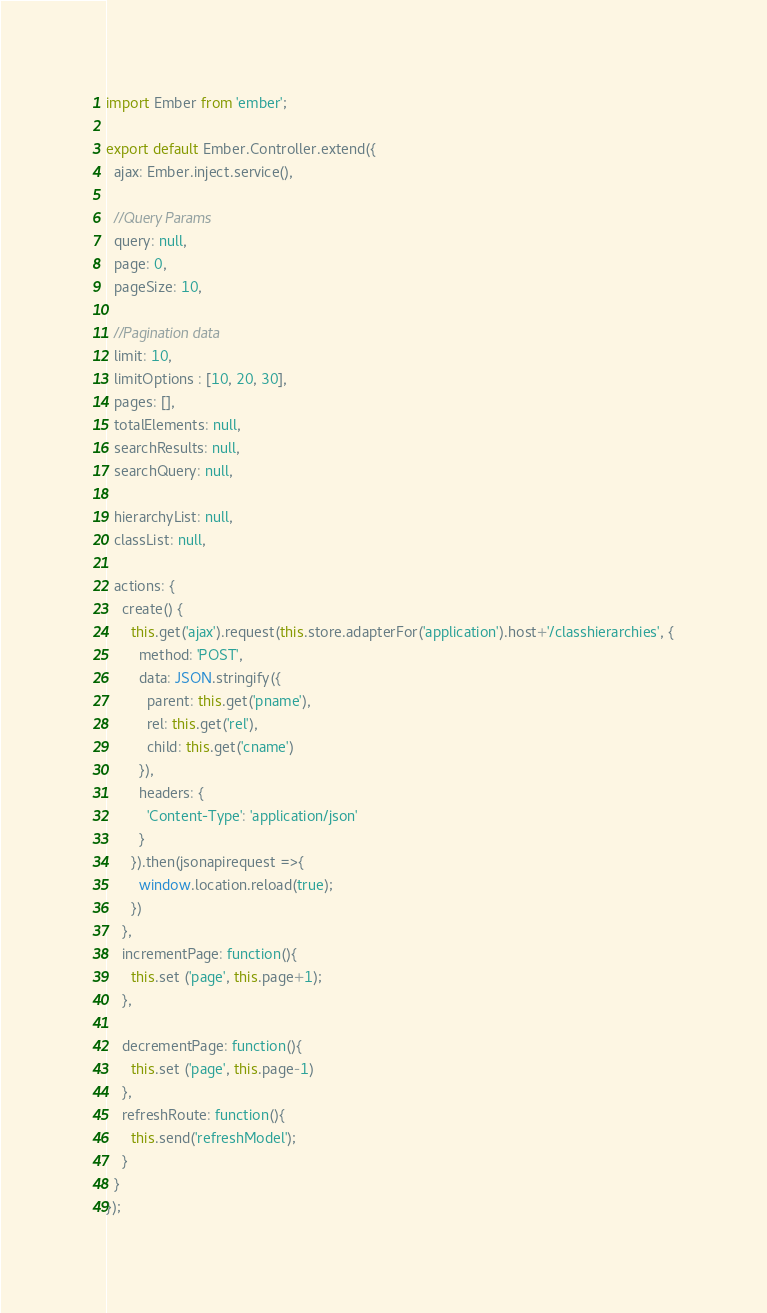<code> <loc_0><loc_0><loc_500><loc_500><_JavaScript_>import Ember from 'ember';

export default Ember.Controller.extend({
  ajax: Ember.inject.service(),

  //Query Params
  query: null,
  page: 0,
  pageSize: 10,

  //Pagination data
  limit: 10,
  limitOptions : [10, 20, 30],
  pages: [],
  totalElements: null,
  searchResults: null,
  searchQuery: null,

  hierarchyList: null,
  classList: null,

  actions: {
    create() {
      this.get('ajax').request(this.store.adapterFor('application').host+'/classhierarchies', {
        method: 'POST',
        data: JSON.stringify({
          parent: this.get('pname'),
          rel: this.get('rel'),
          child: this.get('cname')
        }),
        headers: {
          'Content-Type': 'application/json'
        }
      }).then(jsonapirequest =>{
        window.location.reload(true);
      })
    },
    incrementPage: function(){
      this.set ('page', this.page+1);
    },

    decrementPage: function(){
      this.set ('page', this.page-1)
    },
    refreshRoute: function(){
      this.send('refreshModel');
    }
  }
});
</code> 